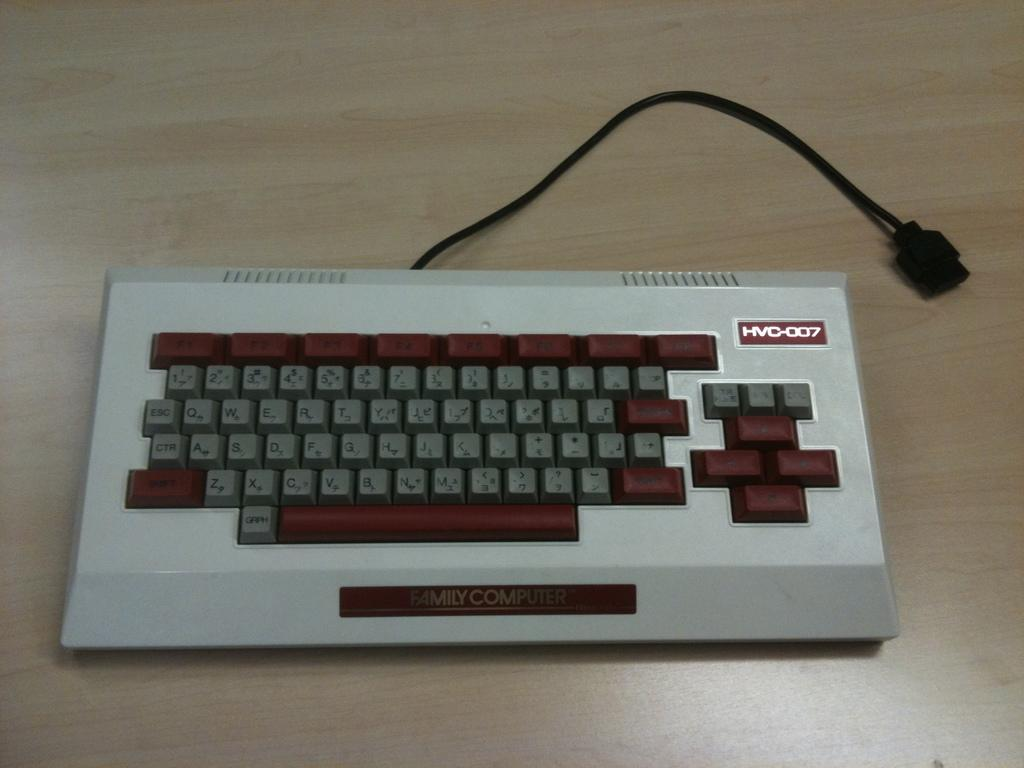<image>
Share a concise interpretation of the image provided. An HVC-007 keyboard has some red keypad buttons. 